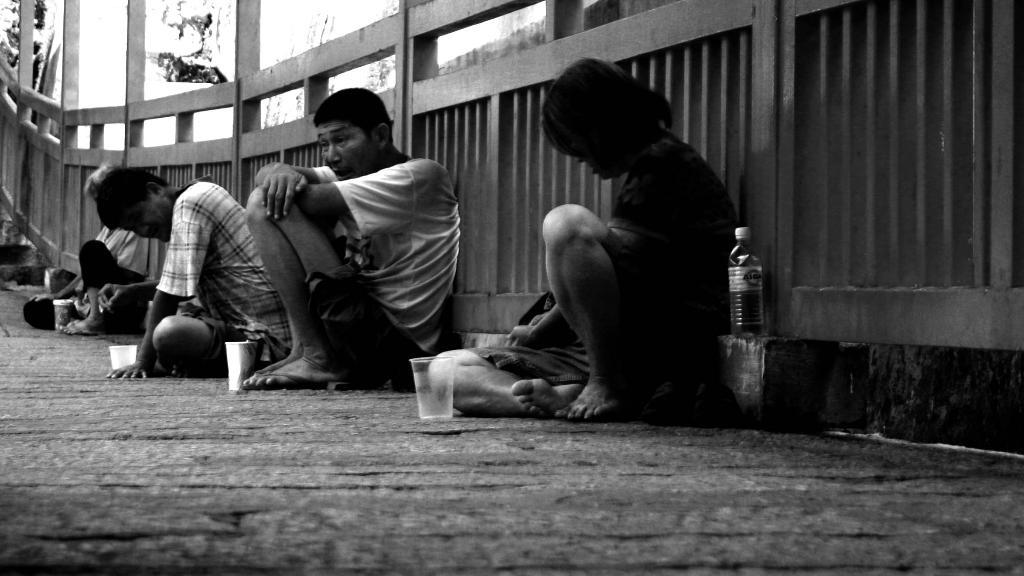How many people are present in the image? There are four people in the image. What are the people doing in the image? The people are sitting on a surface and leaning on a wooden fence. What objects are placed in front of each person? There are four glasses in the image, and each glass is placed in front of one of the people. What type of stick is being used to play with the ball in the image? There is no stick or ball present in the image. How many cups are visible in the image? There are no cups visible in the image; there are only glasses. 